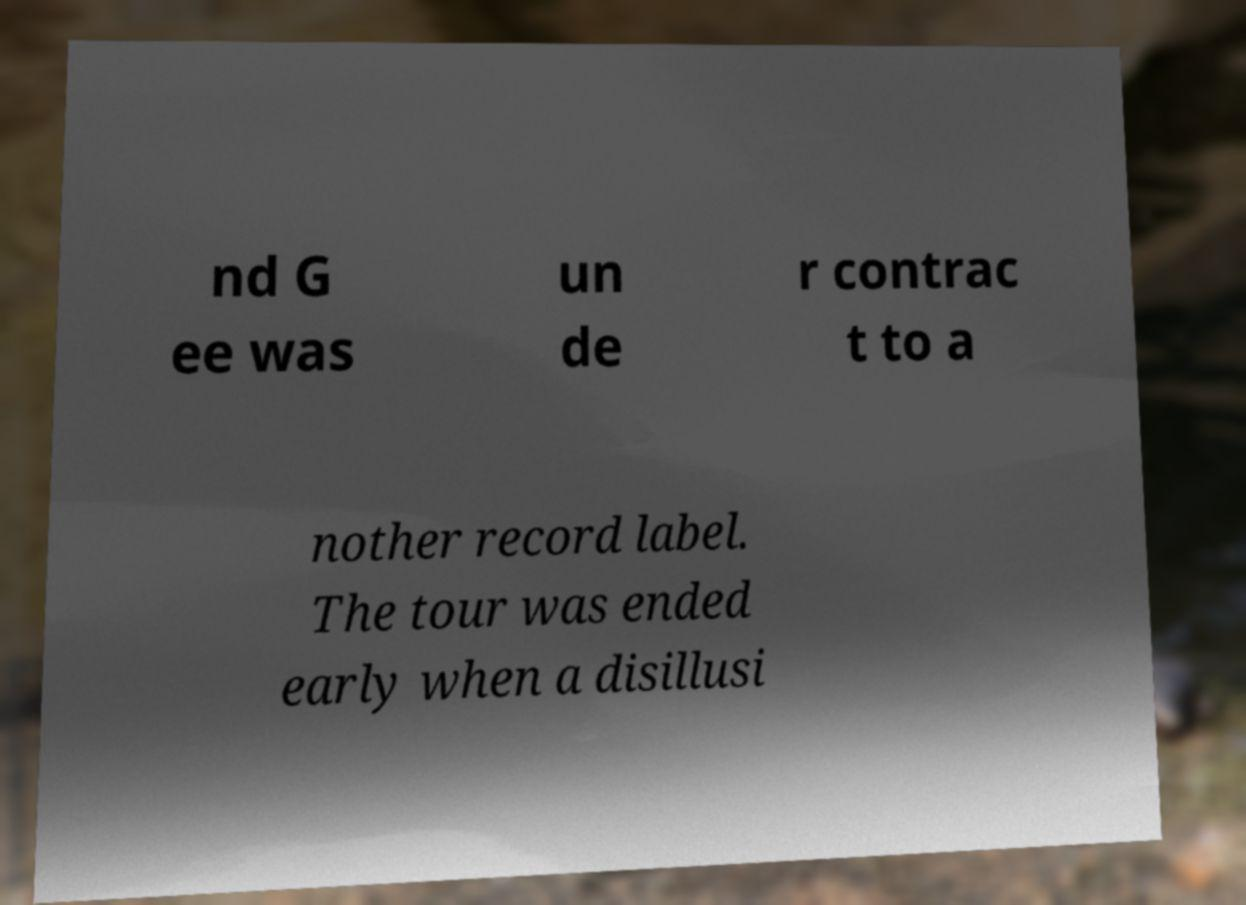I need the written content from this picture converted into text. Can you do that? nd G ee was un de r contrac t to a nother record label. The tour was ended early when a disillusi 